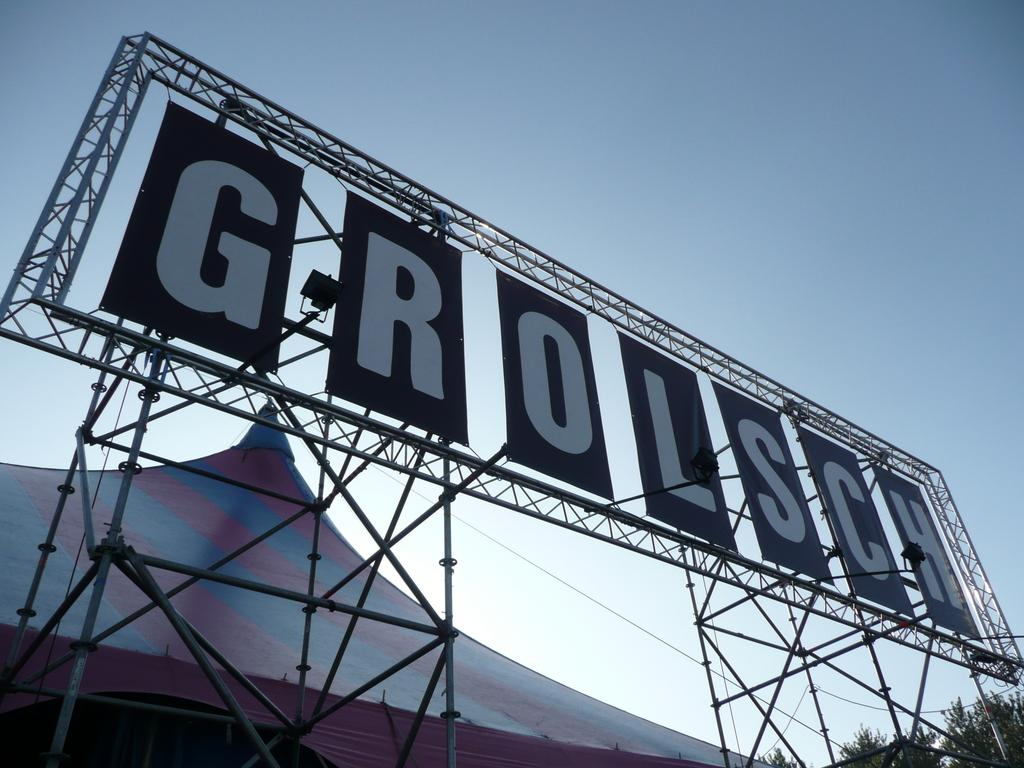What is the main structure visible in the image? There is a hoarding in the image. What other objects can be seen in the image? There are rods, lights, a tent, and trees visible in the image. What is the color of the sky in the background of the image? The background of the image includes a blue sky. Can you tell me how many toads are sitting on the tent in the image? There are no toads present in the image; it only features a hoarding, rods, lights, a tent, trees, and a blue sky in the background. What type of insurance policy is advertised on the hoarding in the image? The image does not provide information about any insurance policy being advertised on the hoarding. 